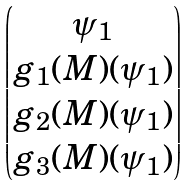<formula> <loc_0><loc_0><loc_500><loc_500>\begin{pmatrix} \psi _ { 1 } \\ g _ { 1 } ( M ) ( \psi _ { 1 } ) \\ g _ { 2 } ( M ) ( \psi _ { 1 } ) \\ g _ { 3 } ( M ) ( \psi _ { 1 } ) \\ \end{pmatrix}</formula> 